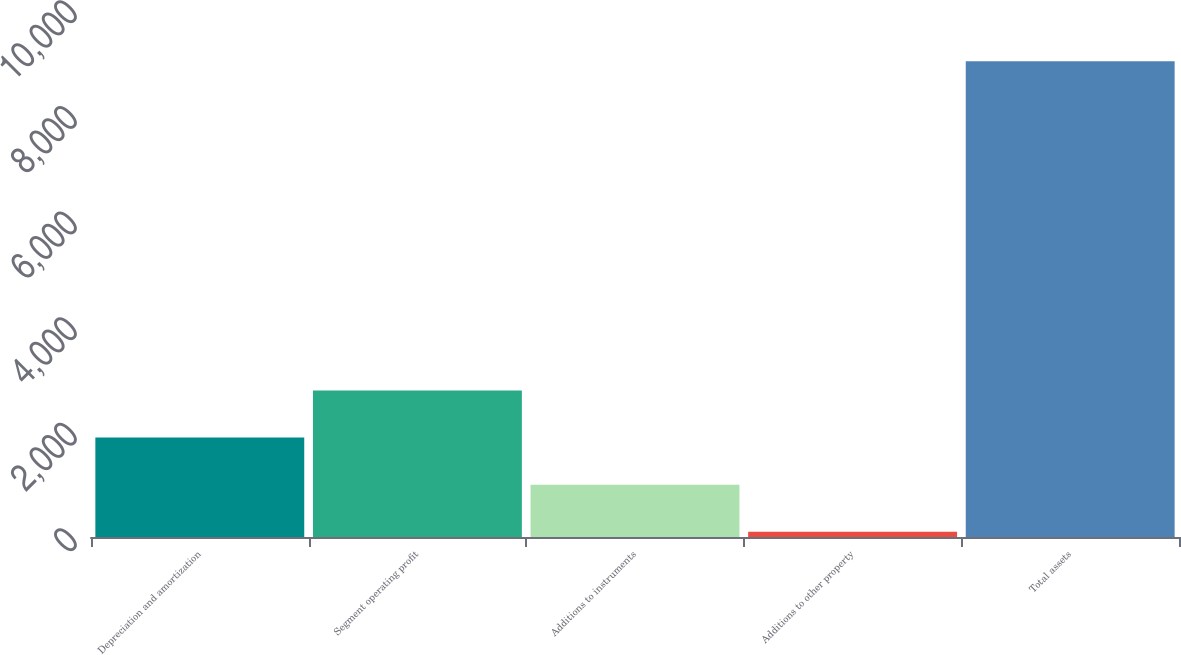<chart> <loc_0><loc_0><loc_500><loc_500><bar_chart><fcel>Depreciation and amortization<fcel>Segment operating profit<fcel>Additions to instruments<fcel>Additions to other property<fcel>Total assets<nl><fcel>1882.48<fcel>2773.72<fcel>991.24<fcel>100<fcel>9012.4<nl></chart> 